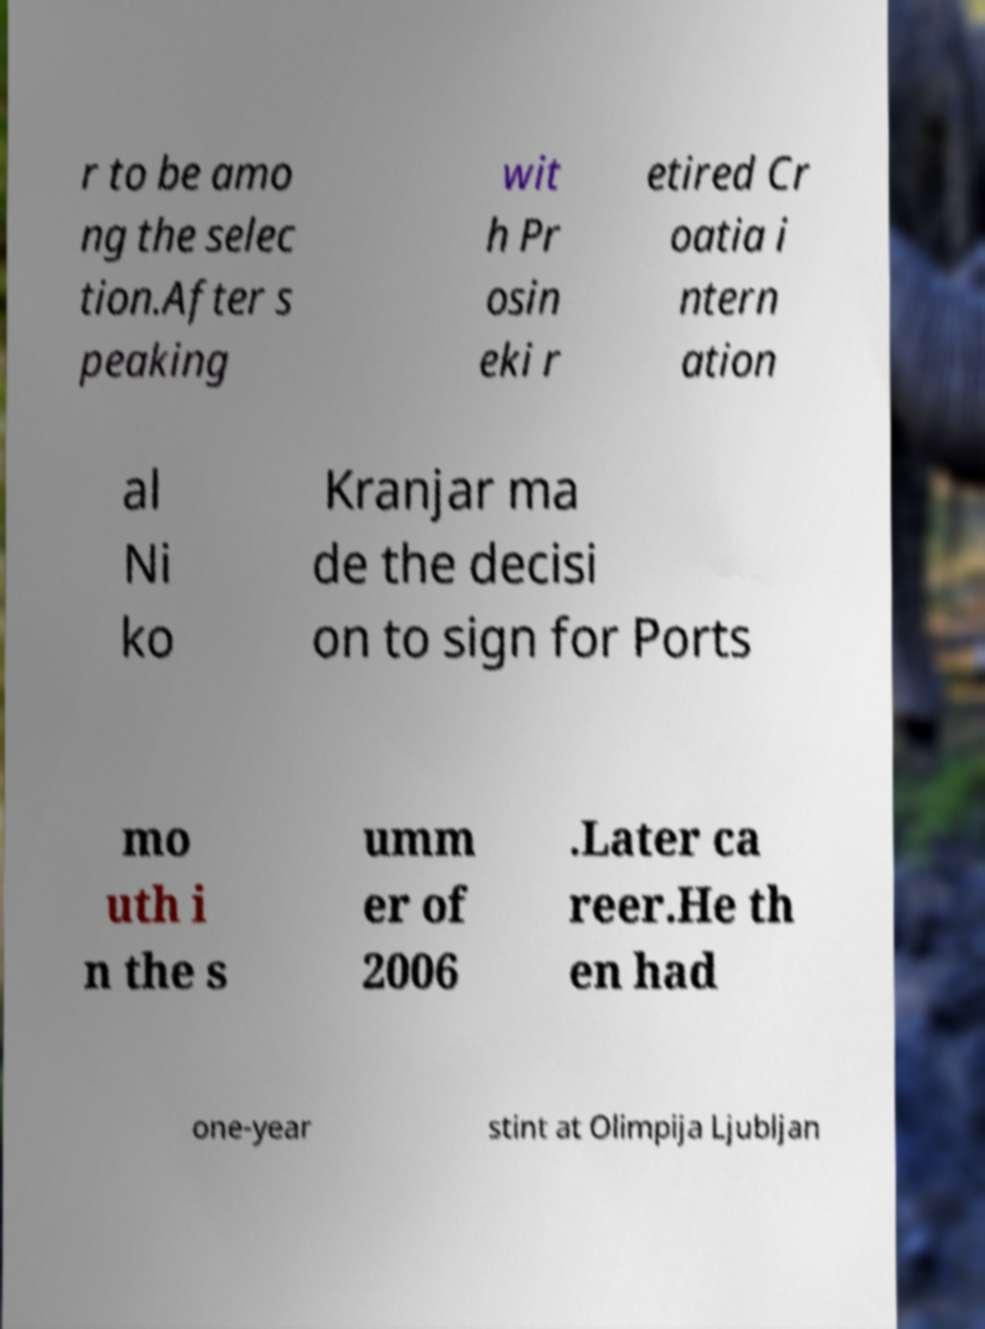Could you extract and type out the text from this image? r to be amo ng the selec tion.After s peaking wit h Pr osin eki r etired Cr oatia i ntern ation al Ni ko Kranjar ma de the decisi on to sign for Ports mo uth i n the s umm er of 2006 .Later ca reer.He th en had one-year stint at Olimpija Ljubljan 